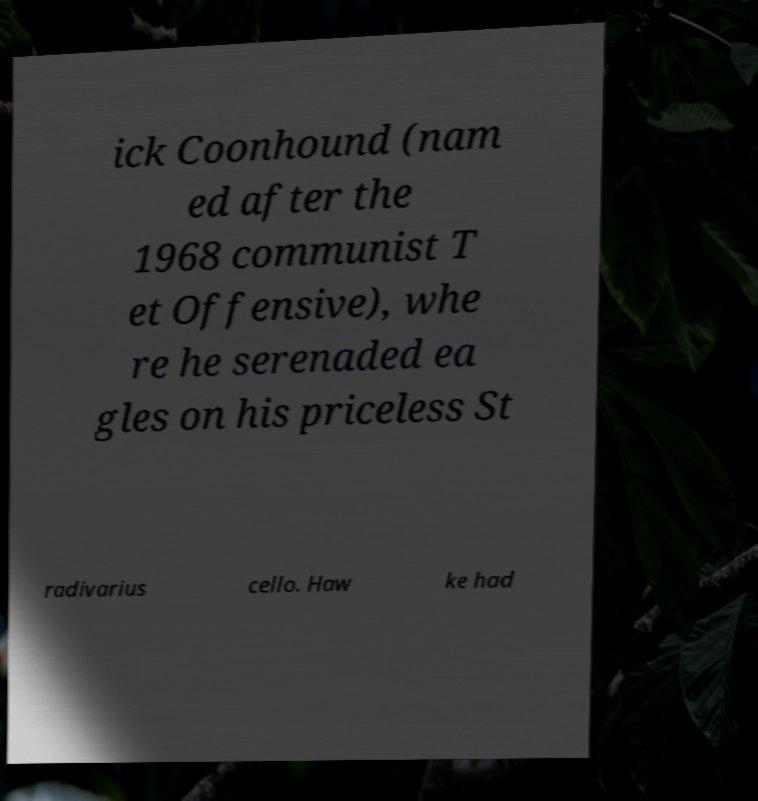Can you read and provide the text displayed in the image?This photo seems to have some interesting text. Can you extract and type it out for me? ick Coonhound (nam ed after the 1968 communist T et Offensive), whe re he serenaded ea gles on his priceless St radivarius cello. Haw ke had 